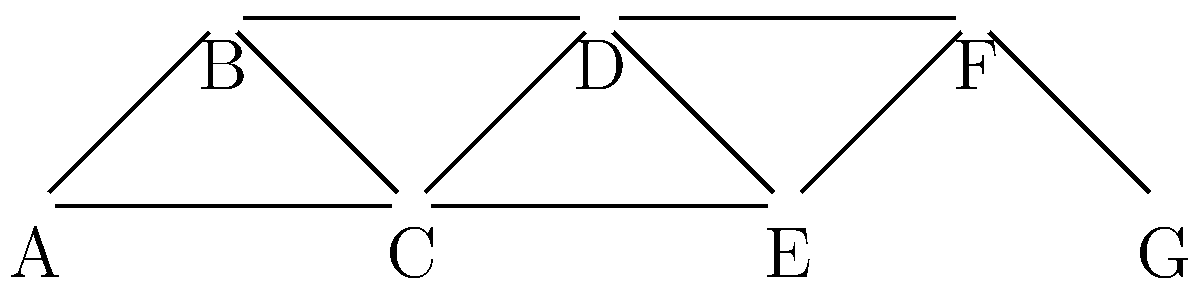Given the co-authorship network shown above, where nodes represent researchers and edges represent collaborations, identify the number of distinct research clusters using the Girvan-Newman algorithm. Assume that the algorithm terminates when the modularity score is maximized. To identify the number of distinct research clusters using the Girvan-Newman algorithm, we follow these steps:

1. Calculate the betweenness centrality for all edges in the network.
2. Remove the edge with the highest betweenness centrality.
3. Recalculate betweenness centralities for all remaining edges.
4. Repeat steps 2 and 3 until the network is fully disconnected.
5. Calculate the modularity score for each division of the network.
6. Choose the division with the highest modularity score.

Let's apply this process to our network:

Step 1: The edge with the highest betweenness centrality is likely C-D, as it connects two dense subgraphs.

Step 2: Remove edge C-D.

Step 3-4: Repeat the process. The next edges to be removed would likely be B-D and C-E.

Step 5-6: After these removals, we have three distinct clusters:
- Cluster 1: A, B, C
- Cluster 2: D, E, F
- Cluster 3: G

This division likely maximizes the modularity score, as it creates dense internal connections within clusters and sparse connections between clusters.

Therefore, the Girvan-Newman algorithm identifies 3 distinct research clusters in this co-authorship network.
Answer: 3 clusters 